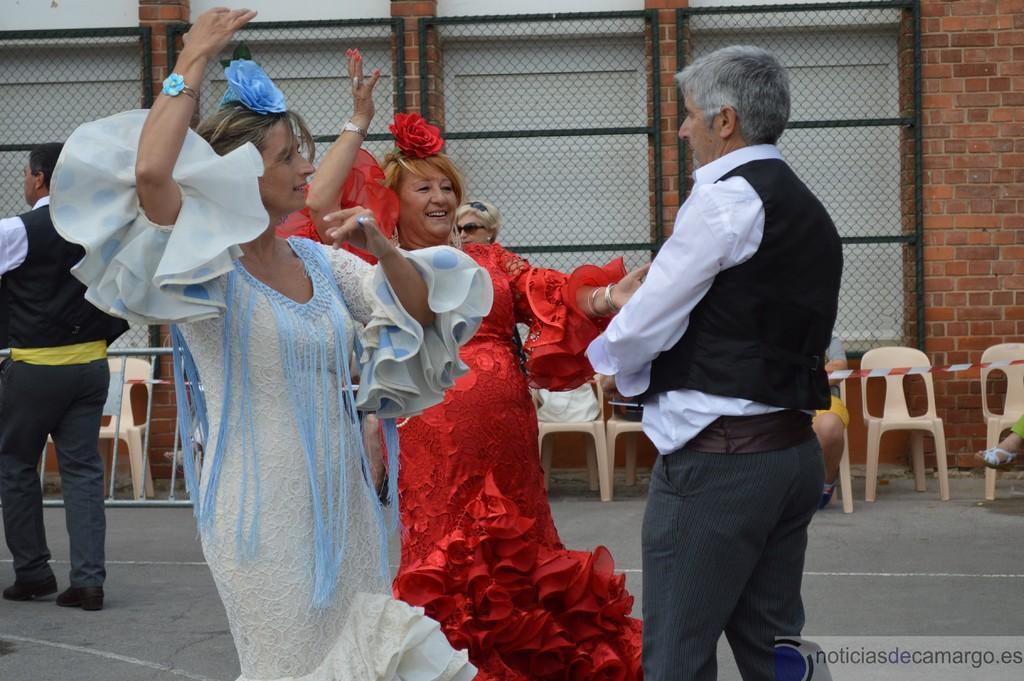How would you summarize this image in a sentence or two? In this image we can see persons standing on the floor and some of them are wearing costumes. In the background we can see chairs, traffic ribbon, iron mesh attached to the wall and persons sitting on the chairs. 